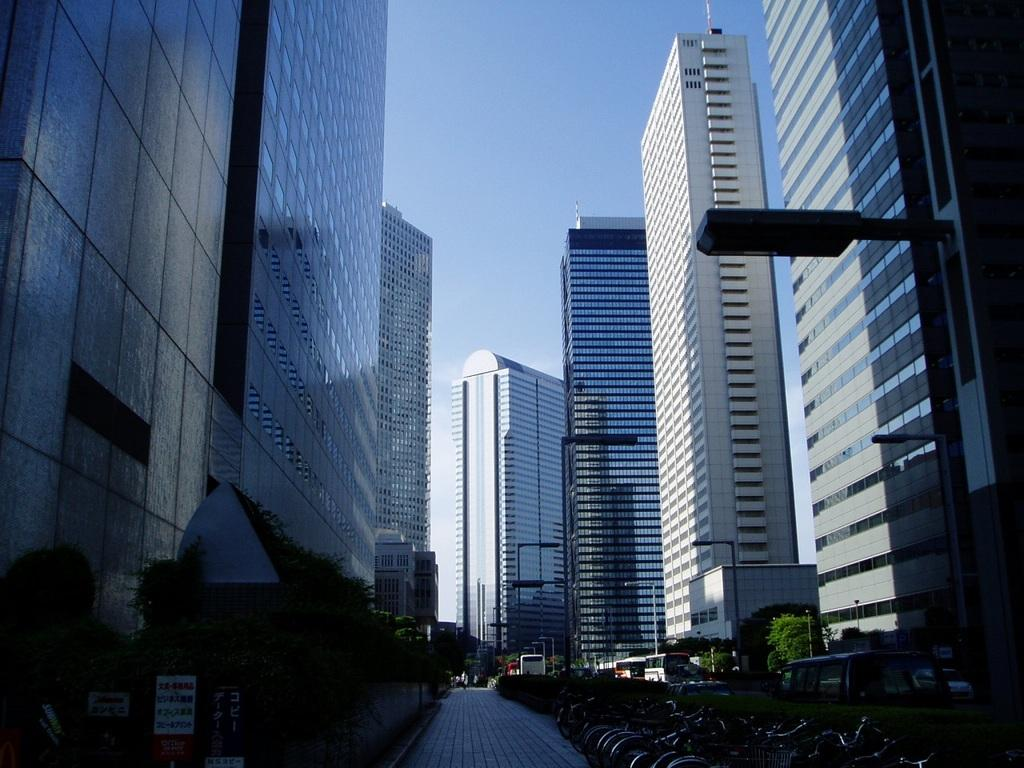What type of structures can be seen in the image? There are buildings in the image. What other natural or man-made elements are present in the image? There are trees, boards, poles, lights, vehicles, and bicycles in the image. What is visible at the top of the image? The sky is visible at the top of the image. Where can the coal be found in the image? There is no coal present in the image. How many heads of the people in the image can be counted? There are no people visible in the image, so it is not possible to count their heads. 